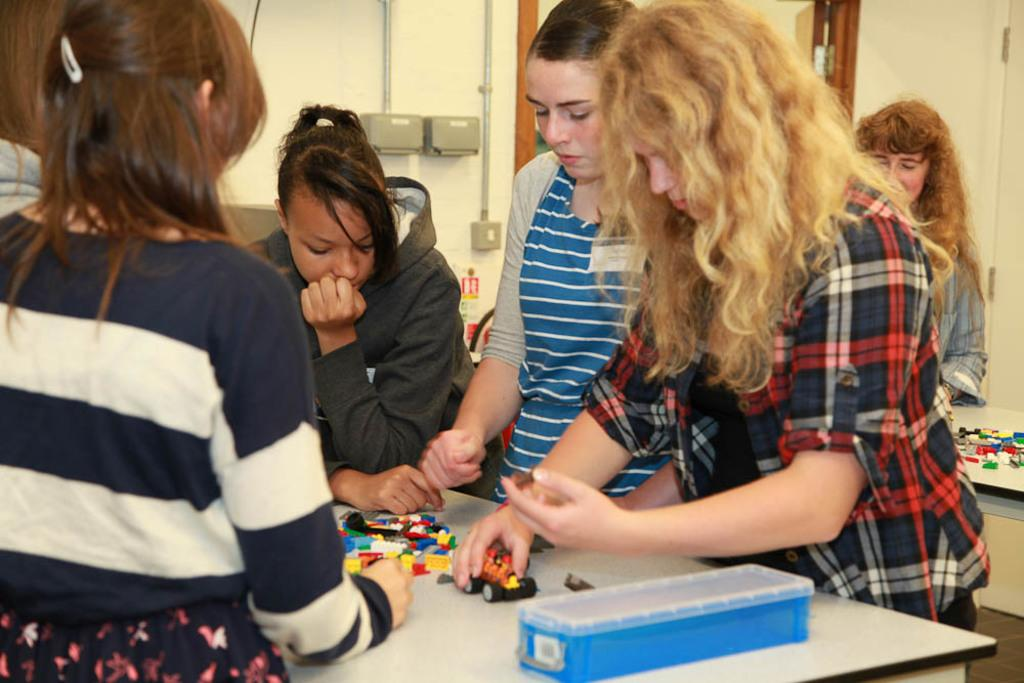Who or what can be seen in the image? There are people in the image. What else is present in the image besides the people? There are toys and a box on a table visible in the image. What type of background can be seen in the image? There is a wall and a door visible in the image. What type of art is the scarecrow creating in the image? There is no scarecrow present in the image, and therefore no art can be observed. 